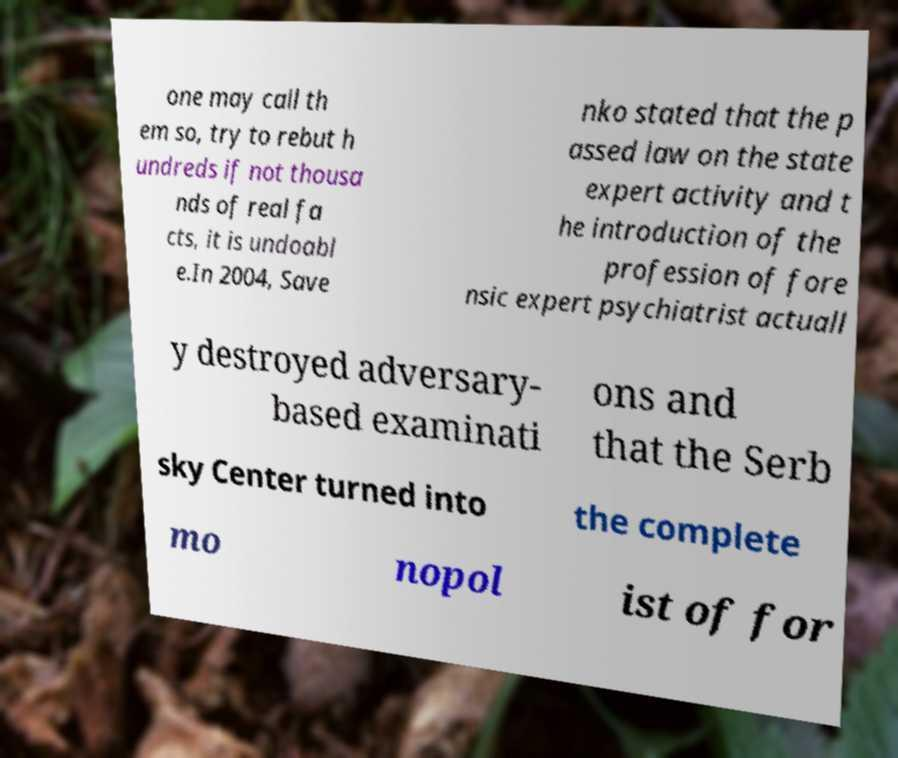Can you accurately transcribe the text from the provided image for me? one may call th em so, try to rebut h undreds if not thousa nds of real fa cts, it is undoabl e.In 2004, Save nko stated that the p assed law on the state expert activity and t he introduction of the profession of fore nsic expert psychiatrist actuall y destroyed adversary- based examinati ons and that the Serb sky Center turned into the complete mo nopol ist of for 